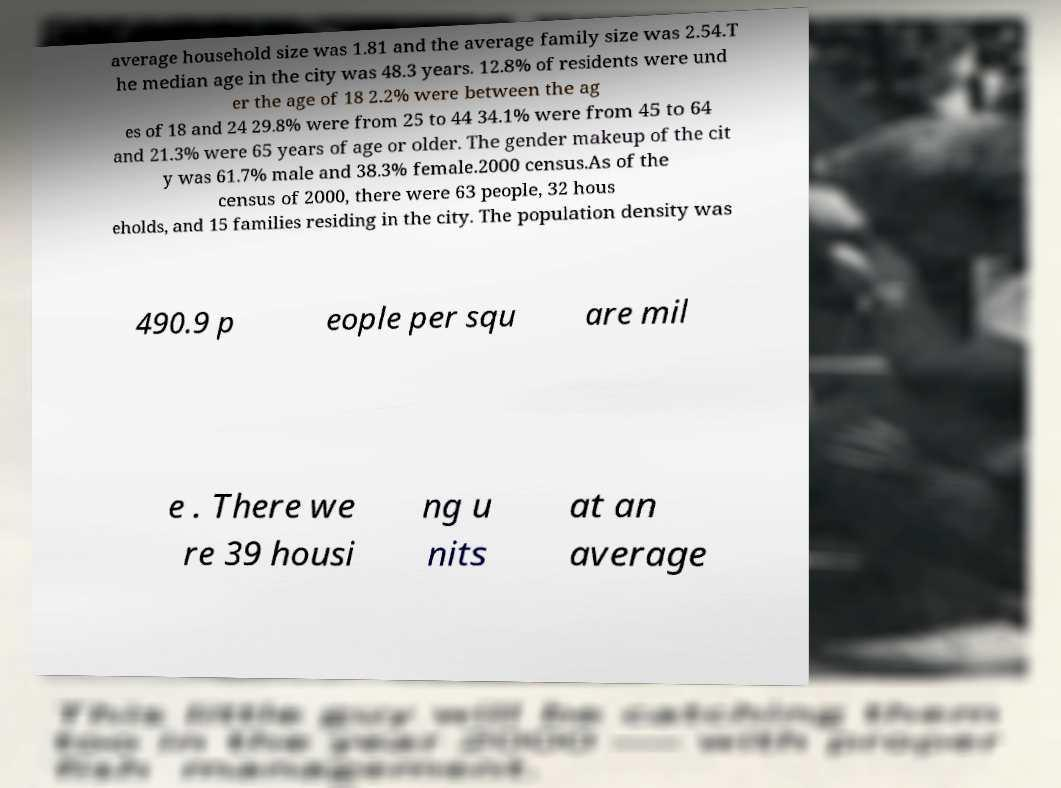Could you extract and type out the text from this image? average household size was 1.81 and the average family size was 2.54.T he median age in the city was 48.3 years. 12.8% of residents were und er the age of 18 2.2% were between the ag es of 18 and 24 29.8% were from 25 to 44 34.1% were from 45 to 64 and 21.3% were 65 years of age or older. The gender makeup of the cit y was 61.7% male and 38.3% female.2000 census.As of the census of 2000, there were 63 people, 32 hous eholds, and 15 families residing in the city. The population density was 490.9 p eople per squ are mil e . There we re 39 housi ng u nits at an average 